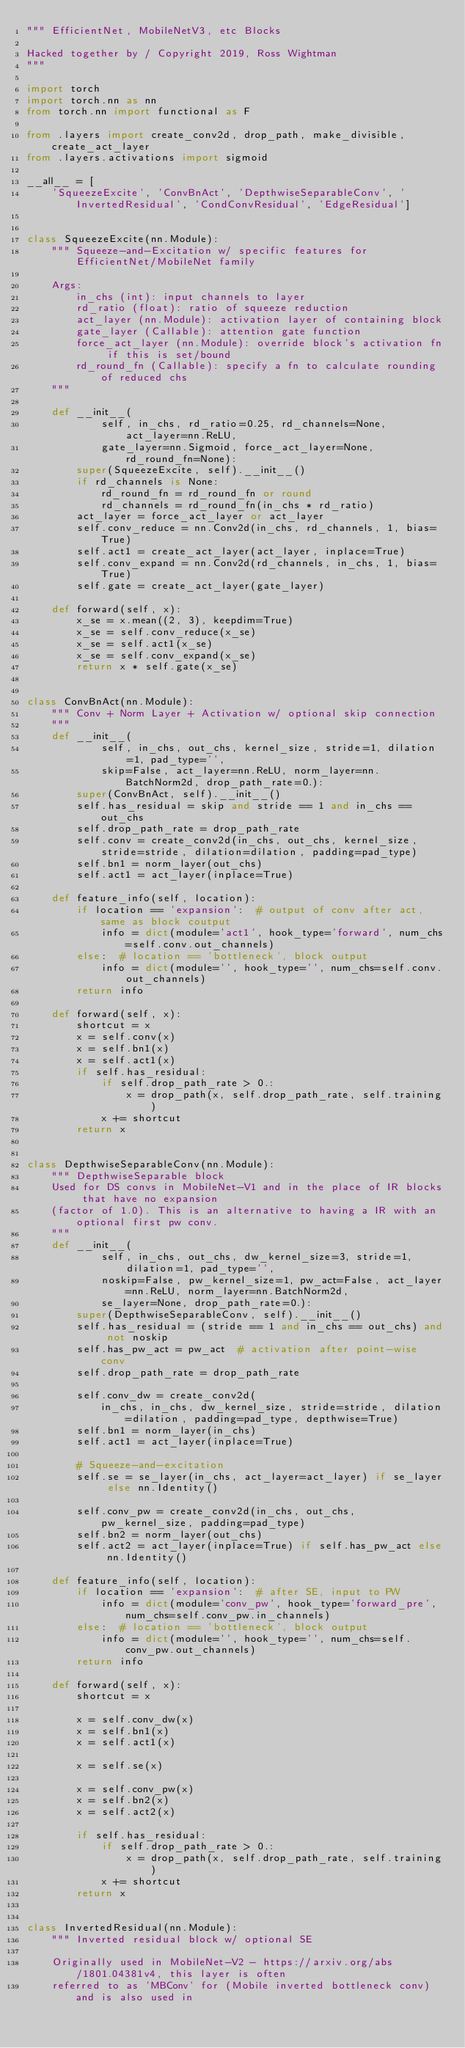Convert code to text. <code><loc_0><loc_0><loc_500><loc_500><_Python_>""" EfficientNet, MobileNetV3, etc Blocks

Hacked together by / Copyright 2019, Ross Wightman
"""

import torch
import torch.nn as nn
from torch.nn import functional as F

from .layers import create_conv2d, drop_path, make_divisible, create_act_layer
from .layers.activations import sigmoid

__all__ = [
    'SqueezeExcite', 'ConvBnAct', 'DepthwiseSeparableConv', 'InvertedResidual', 'CondConvResidual', 'EdgeResidual']


class SqueezeExcite(nn.Module):
    """ Squeeze-and-Excitation w/ specific features for EfficientNet/MobileNet family

    Args:
        in_chs (int): input channels to layer
        rd_ratio (float): ratio of squeeze reduction
        act_layer (nn.Module): activation layer of containing block
        gate_layer (Callable): attention gate function
        force_act_layer (nn.Module): override block's activation fn if this is set/bound
        rd_round_fn (Callable): specify a fn to calculate rounding of reduced chs
    """

    def __init__(
            self, in_chs, rd_ratio=0.25, rd_channels=None, act_layer=nn.ReLU,
            gate_layer=nn.Sigmoid, force_act_layer=None, rd_round_fn=None):
        super(SqueezeExcite, self).__init__()
        if rd_channels is None:
            rd_round_fn = rd_round_fn or round
            rd_channels = rd_round_fn(in_chs * rd_ratio)
        act_layer = force_act_layer or act_layer
        self.conv_reduce = nn.Conv2d(in_chs, rd_channels, 1, bias=True)
        self.act1 = create_act_layer(act_layer, inplace=True)
        self.conv_expand = nn.Conv2d(rd_channels, in_chs, 1, bias=True)
        self.gate = create_act_layer(gate_layer)

    def forward(self, x):
        x_se = x.mean((2, 3), keepdim=True)
        x_se = self.conv_reduce(x_se)
        x_se = self.act1(x_se)
        x_se = self.conv_expand(x_se)
        return x * self.gate(x_se)


class ConvBnAct(nn.Module):
    """ Conv + Norm Layer + Activation w/ optional skip connection
    """
    def __init__(
            self, in_chs, out_chs, kernel_size, stride=1, dilation=1, pad_type='',
            skip=False, act_layer=nn.ReLU, norm_layer=nn.BatchNorm2d, drop_path_rate=0.):
        super(ConvBnAct, self).__init__()
        self.has_residual = skip and stride == 1 and in_chs == out_chs
        self.drop_path_rate = drop_path_rate
        self.conv = create_conv2d(in_chs, out_chs, kernel_size, stride=stride, dilation=dilation, padding=pad_type)
        self.bn1 = norm_layer(out_chs)
        self.act1 = act_layer(inplace=True)

    def feature_info(self, location):
        if location == 'expansion':  # output of conv after act, same as block coutput
            info = dict(module='act1', hook_type='forward', num_chs=self.conv.out_channels)
        else:  # location == 'bottleneck', block output
            info = dict(module='', hook_type='', num_chs=self.conv.out_channels)
        return info

    def forward(self, x):
        shortcut = x
        x = self.conv(x)
        x = self.bn1(x)
        x = self.act1(x)
        if self.has_residual:
            if self.drop_path_rate > 0.:
                x = drop_path(x, self.drop_path_rate, self.training)
            x += shortcut
        return x


class DepthwiseSeparableConv(nn.Module):
    """ DepthwiseSeparable block
    Used for DS convs in MobileNet-V1 and in the place of IR blocks that have no expansion
    (factor of 1.0). This is an alternative to having a IR with an optional first pw conv.
    """
    def __init__(
            self, in_chs, out_chs, dw_kernel_size=3, stride=1, dilation=1, pad_type='',
            noskip=False, pw_kernel_size=1, pw_act=False, act_layer=nn.ReLU, norm_layer=nn.BatchNorm2d,
            se_layer=None, drop_path_rate=0.):
        super(DepthwiseSeparableConv, self).__init__()
        self.has_residual = (stride == 1 and in_chs == out_chs) and not noskip
        self.has_pw_act = pw_act  # activation after point-wise conv
        self.drop_path_rate = drop_path_rate

        self.conv_dw = create_conv2d(
            in_chs, in_chs, dw_kernel_size, stride=stride, dilation=dilation, padding=pad_type, depthwise=True)
        self.bn1 = norm_layer(in_chs)
        self.act1 = act_layer(inplace=True)

        # Squeeze-and-excitation
        self.se = se_layer(in_chs, act_layer=act_layer) if se_layer else nn.Identity()

        self.conv_pw = create_conv2d(in_chs, out_chs, pw_kernel_size, padding=pad_type)
        self.bn2 = norm_layer(out_chs)
        self.act2 = act_layer(inplace=True) if self.has_pw_act else nn.Identity()

    def feature_info(self, location):
        if location == 'expansion':  # after SE, input to PW
            info = dict(module='conv_pw', hook_type='forward_pre', num_chs=self.conv_pw.in_channels)
        else:  # location == 'bottleneck', block output
            info = dict(module='', hook_type='', num_chs=self.conv_pw.out_channels)
        return info

    def forward(self, x):
        shortcut = x

        x = self.conv_dw(x)
        x = self.bn1(x)
        x = self.act1(x)

        x = self.se(x)

        x = self.conv_pw(x)
        x = self.bn2(x)
        x = self.act2(x)

        if self.has_residual:
            if self.drop_path_rate > 0.:
                x = drop_path(x, self.drop_path_rate, self.training)
            x += shortcut
        return x


class InvertedResidual(nn.Module):
    """ Inverted residual block w/ optional SE

    Originally used in MobileNet-V2 - https://arxiv.org/abs/1801.04381v4, this layer is often
    referred to as 'MBConv' for (Mobile inverted bottleneck conv) and is also used in</code> 